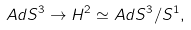Convert formula to latex. <formula><loc_0><loc_0><loc_500><loc_500>A d S ^ { 3 } \rightarrow H ^ { 2 } \simeq A d S ^ { 3 } / S ^ { 1 } ,</formula> 